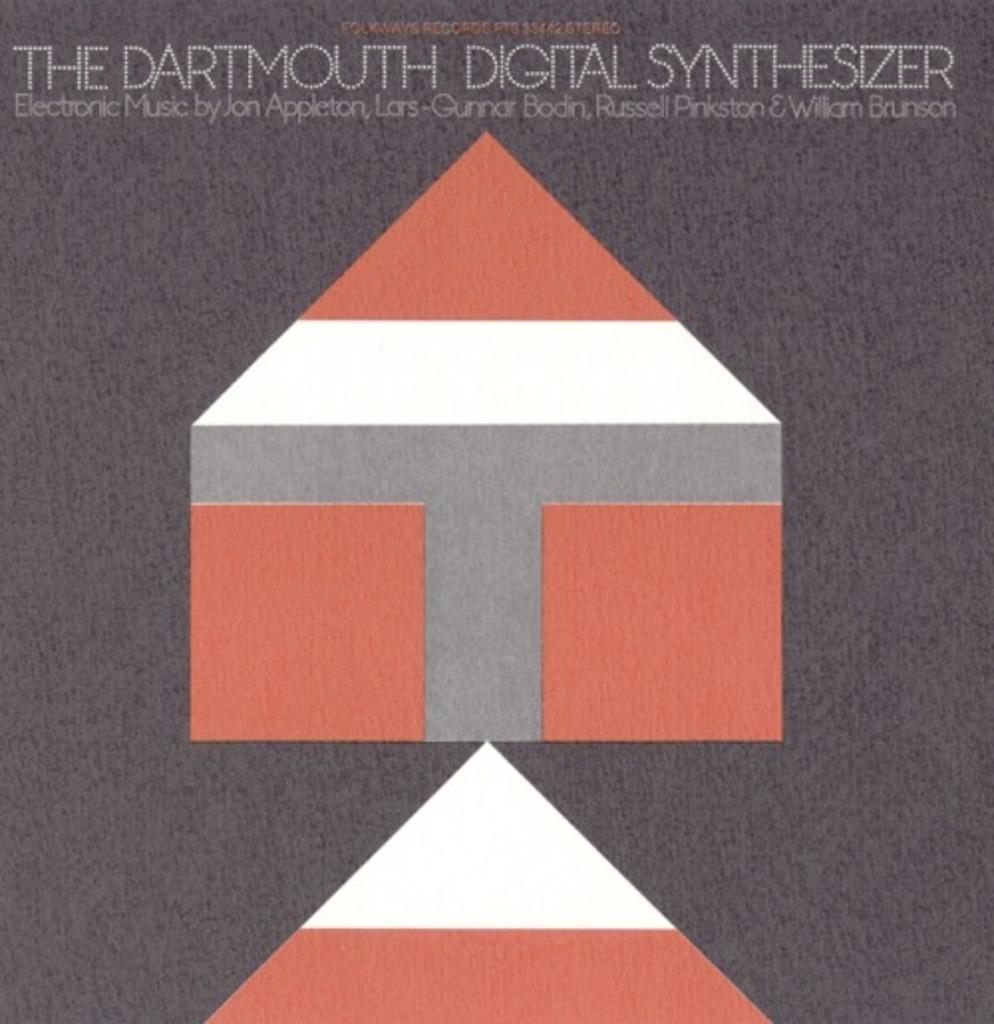Provide a one-sentence caption for the provided image. Poster which shows a shape of a house and says "The Dartmouth Ditital Synthesizer". 